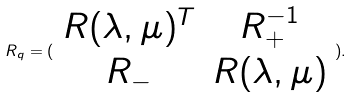<formula> <loc_0><loc_0><loc_500><loc_500>R _ { q } = ( \begin{array} { c c } R ( \lambda , \mu ) ^ { T } & R _ { + } ^ { - 1 } \\ R _ { - } & R ( \lambda , \mu ) \end{array} ) .</formula> 